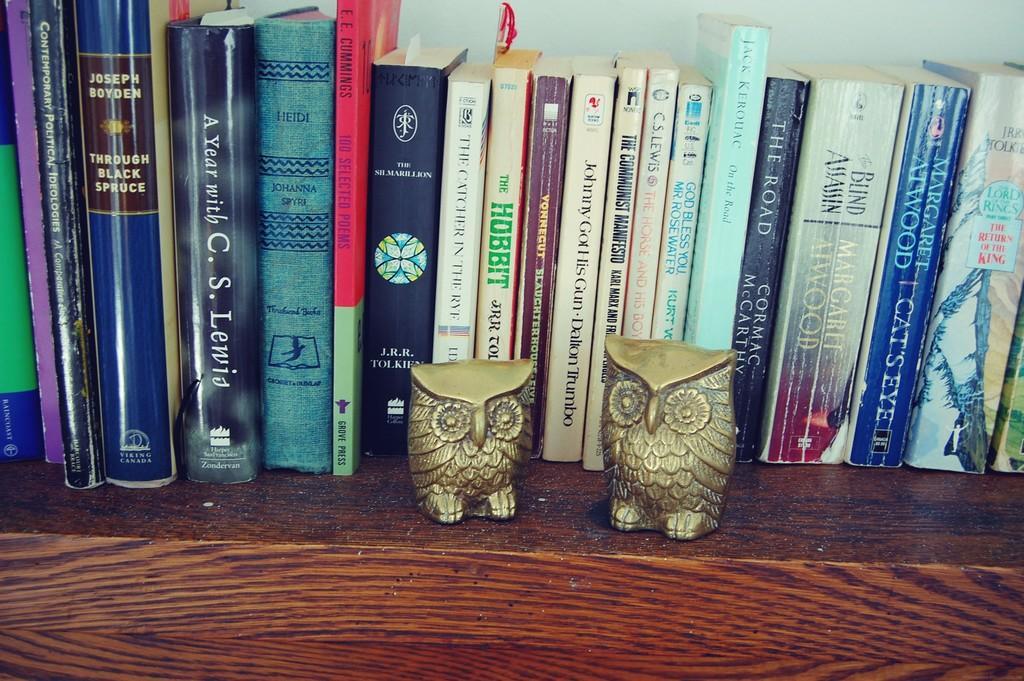Can you describe this image briefly? In this image in the front there are objects which are golden in colour and in the background there are books. 